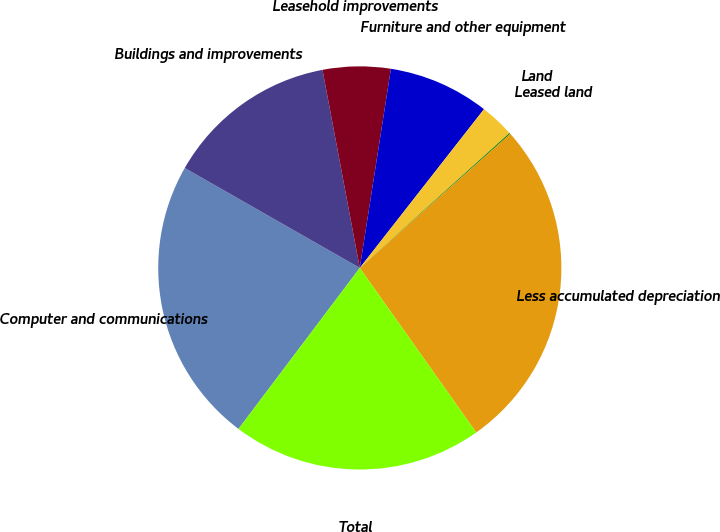Convert chart. <chart><loc_0><loc_0><loc_500><loc_500><pie_chart><fcel>Computer and communications<fcel>Buildings and improvements<fcel>Leasehold improvements<fcel>Furniture and other equipment<fcel>Land<fcel>Leased land<fcel>Less accumulated depreciation<fcel>Total<nl><fcel>22.98%<fcel>13.78%<fcel>5.43%<fcel>8.1%<fcel>2.76%<fcel>0.09%<fcel>26.78%<fcel>20.08%<nl></chart> 